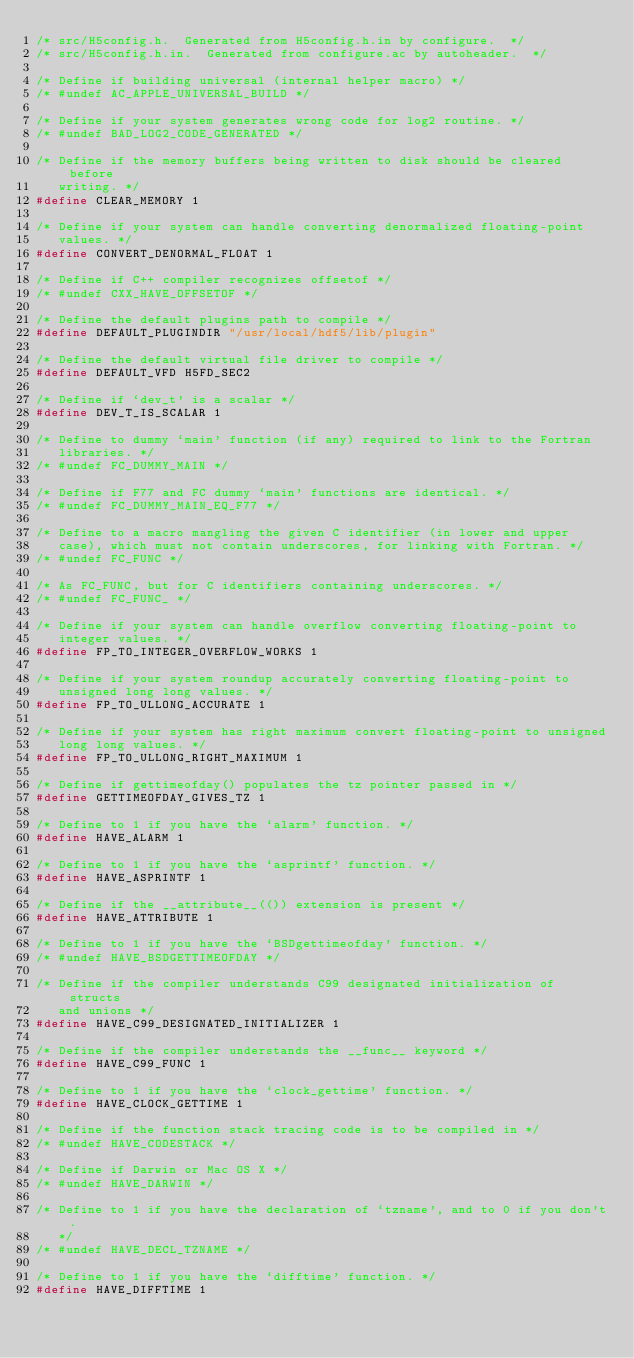<code> <loc_0><loc_0><loc_500><loc_500><_C_>/* src/H5config.h.  Generated from H5config.h.in by configure.  */
/* src/H5config.h.in.  Generated from configure.ac by autoheader.  */

/* Define if building universal (internal helper macro) */
/* #undef AC_APPLE_UNIVERSAL_BUILD */

/* Define if your system generates wrong code for log2 routine. */
/* #undef BAD_LOG2_CODE_GENERATED */

/* Define if the memory buffers being written to disk should be cleared before
   writing. */
#define CLEAR_MEMORY 1

/* Define if your system can handle converting denormalized floating-point
   values. */
#define CONVERT_DENORMAL_FLOAT 1

/* Define if C++ compiler recognizes offsetof */
/* #undef CXX_HAVE_OFFSETOF */

/* Define the default plugins path to compile */
#define DEFAULT_PLUGINDIR "/usr/local/hdf5/lib/plugin"

/* Define the default virtual file driver to compile */
#define DEFAULT_VFD H5FD_SEC2

/* Define if `dev_t' is a scalar */
#define DEV_T_IS_SCALAR 1

/* Define to dummy `main' function (if any) required to link to the Fortran
   libraries. */
/* #undef FC_DUMMY_MAIN */

/* Define if F77 and FC dummy `main' functions are identical. */
/* #undef FC_DUMMY_MAIN_EQ_F77 */

/* Define to a macro mangling the given C identifier (in lower and upper
   case), which must not contain underscores, for linking with Fortran. */
/* #undef FC_FUNC */

/* As FC_FUNC, but for C identifiers containing underscores. */
/* #undef FC_FUNC_ */

/* Define if your system can handle overflow converting floating-point to
   integer values. */
#define FP_TO_INTEGER_OVERFLOW_WORKS 1

/* Define if your system roundup accurately converting floating-point to
   unsigned long long values. */
#define FP_TO_ULLONG_ACCURATE 1

/* Define if your system has right maximum convert floating-point to unsigned
   long long values. */
#define FP_TO_ULLONG_RIGHT_MAXIMUM 1

/* Define if gettimeofday() populates the tz pointer passed in */
#define GETTIMEOFDAY_GIVES_TZ 1

/* Define to 1 if you have the `alarm' function. */
#define HAVE_ALARM 1

/* Define to 1 if you have the `asprintf' function. */
#define HAVE_ASPRINTF 1

/* Define if the __attribute__(()) extension is present */
#define HAVE_ATTRIBUTE 1

/* Define to 1 if you have the `BSDgettimeofday' function. */
/* #undef HAVE_BSDGETTIMEOFDAY */

/* Define if the compiler understands C99 designated initialization of structs
   and unions */
#define HAVE_C99_DESIGNATED_INITIALIZER 1

/* Define if the compiler understands the __func__ keyword */
#define HAVE_C99_FUNC 1

/* Define to 1 if you have the `clock_gettime' function. */
#define HAVE_CLOCK_GETTIME 1

/* Define if the function stack tracing code is to be compiled in */
/* #undef HAVE_CODESTACK */

/* Define if Darwin or Mac OS X */
/* #undef HAVE_DARWIN */

/* Define to 1 if you have the declaration of `tzname', and to 0 if you don't.
   */
/* #undef HAVE_DECL_TZNAME */

/* Define to 1 if you have the `difftime' function. */
#define HAVE_DIFFTIME 1
</code> 